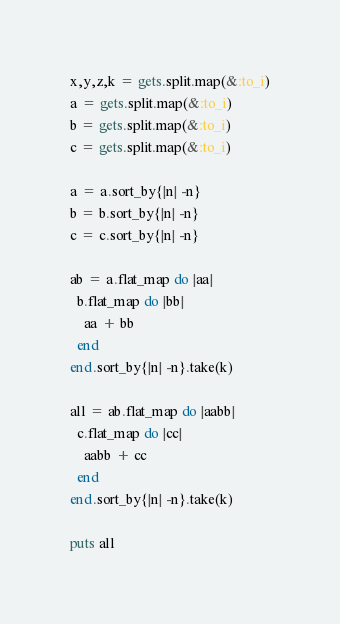<code> <loc_0><loc_0><loc_500><loc_500><_Ruby_>x,y,z,k = gets.split.map(&:to_i)
a = gets.split.map(&:to_i)
b = gets.split.map(&:to_i)
c = gets.split.map(&:to_i)

a = a.sort_by{|n| -n}
b = b.sort_by{|n| -n}
c = c.sort_by{|n| -n}

ab = a.flat_map do |aa|
  b.flat_map do |bb|
    aa + bb
  end
end.sort_by{|n| -n}.take(k)

all = ab.flat_map do |aabb|
  c.flat_map do |cc|
    aabb + cc
  end
end.sort_by{|n| -n}.take(k)

puts all
</code> 